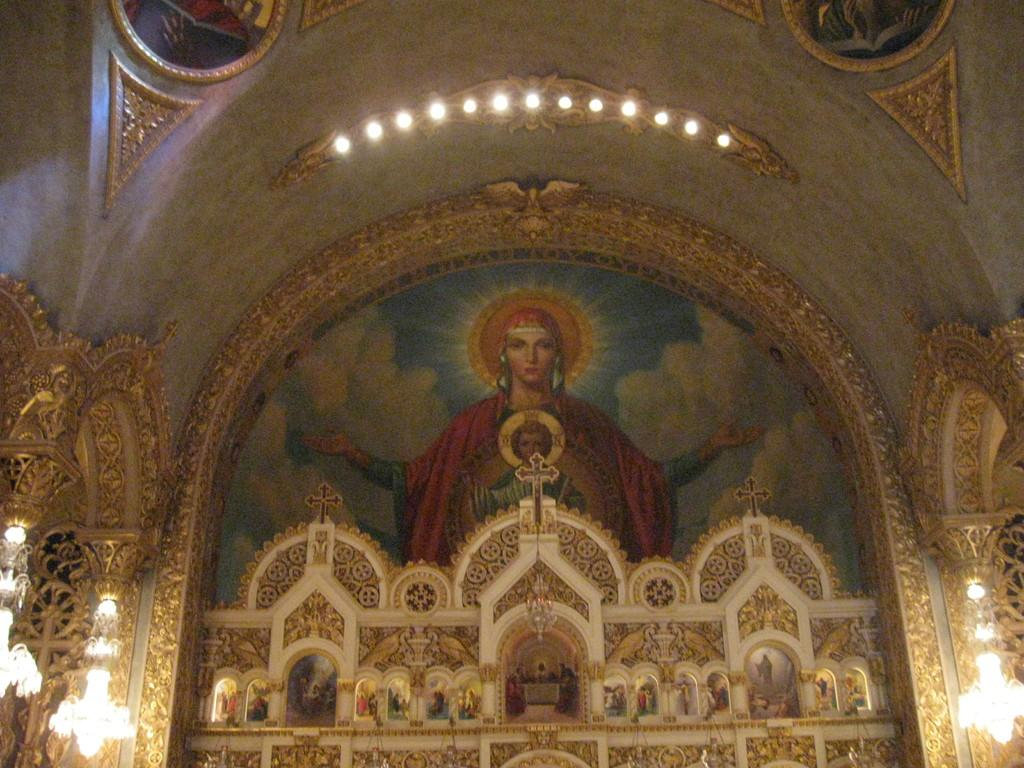Where was the image taken? The image was taken inside a building. What can be seen in the center of the image? There is a wall painting in the center of the image. What is located at the bottom of the image? There is an alter at the bottom of the image. What type of lighting is present in the image? Lights and chandeliers are present in the image. What type of powder is being used to clean the wall painting in the image? There is no indication of any cleaning activity or powder in the image. 